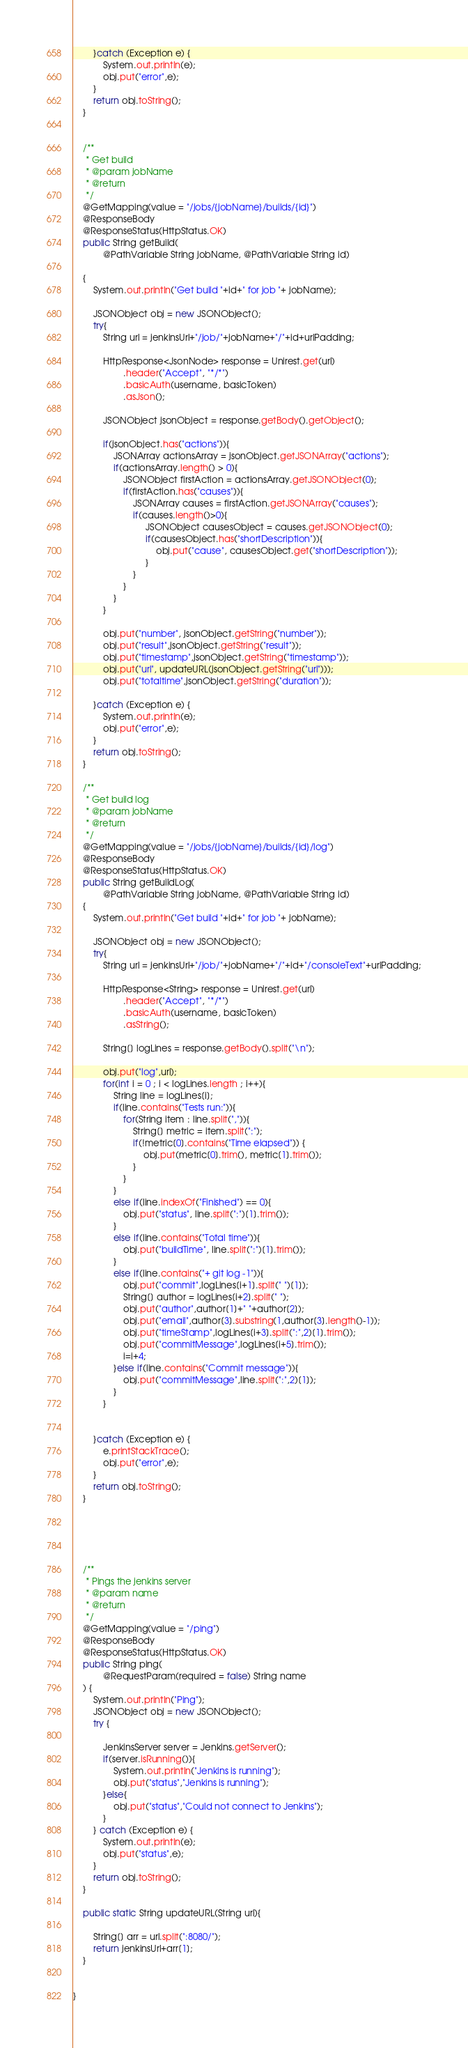Convert code to text. <code><loc_0><loc_0><loc_500><loc_500><_Java_>        }catch (Exception e) {
            System.out.println(e);
            obj.put("error",e);
        }
        return obj.toString();
    }


    /**
     * Get build
     * @param jobName
     * @return
     */
    @GetMapping(value = "/jobs/{jobName}/builds/{id}")
    @ResponseBody
    @ResponseStatus(HttpStatus.OK)
    public String getBuild(
            @PathVariable String jobName, @PathVariable String id)

    {
        System.out.println("Get build "+id+" for job "+ jobName);

        JSONObject obj = new JSONObject();
        try{
            String url = jenkinsUrl+"/job/"+jobName+"/"+id+urlPadding;

            HttpResponse<JsonNode> response = Unirest.get(url)
                    .header("Accept", "*/*")
                    .basicAuth(username, basicToken)
                    .asJson();

            JSONObject jsonObject = response.getBody().getObject();

            if(jsonObject.has("actions")){
                JSONArray actionsArray = jsonObject.getJSONArray("actions");
                if(actionsArray.length() > 0){
                    JSONObject firstAction = actionsArray.getJSONObject(0);
                    if(firstAction.has("causes")){
                        JSONArray causes = firstAction.getJSONArray("causes");
                        if(causes.length()>0){
                             JSONObject causesObject = causes.getJSONObject(0);
                             if(causesObject.has("shortDescription")){
                                 obj.put("cause", causesObject.get("shortDescription"));
                             }
                        }
                    }
                }
            }

            obj.put("number", jsonObject.getString("number"));
            obj.put("result",jsonObject.getString("result"));
            obj.put("timestamp",jsonObject.getString("timestamp"));
            obj.put("url", updateURL(jsonObject.getString("url")));
            obj.put("totaltime",jsonObject.getString("duration"));

        }catch (Exception e) {
            System.out.println(e);
            obj.put("error",e);
        }
        return obj.toString();
    }

    /**
     * Get build log
     * @param jobName
     * @return
     */
    @GetMapping(value = "/jobs/{jobName}/builds/{id}/log")
    @ResponseBody
    @ResponseStatus(HttpStatus.OK)
    public String getBuildLog(
            @PathVariable String jobName, @PathVariable String id)
    {
        System.out.println("Get build "+id+" for job "+ jobName);

        JSONObject obj = new JSONObject();
        try{
            String url = jenkinsUrl+"/job/"+jobName+"/"+id+"/consoleText"+urlPadding;

            HttpResponse<String> response = Unirest.get(url)
                    .header("Accept", "*/*")
                    .basicAuth(username, basicToken)
                    .asString();

            String[] logLines = response.getBody().split("\n");

            obj.put("log",url);
            for(int i = 0 ; i < logLines.length ; i++){
                String line = logLines[i];
                if(line.contains("Tests run:")){
                    for(String item : line.split(",")){
                        String[] metric = item.split(":");
                        if(!metric[0].contains("Time elapsed")) {
                            obj.put(metric[0].trim(), metric[1].trim());
                        }
                    }
                }
                else if(line.indexOf("Finished") == 0){
                    obj.put("status", line.split(":")[1].trim());
                }
                else if(line.contains("Total time")){
                    obj.put("buildTime", line.split(":")[1].trim());
                }
                else if(line.contains("+ git log -1")){
                    obj.put("commit",logLines[i+1].split(" ")[1]);
                    String[] author = logLines[i+2].split(" ");
                    obj.put("author",author[1]+" "+author[2]);
                    obj.put("email",author[3].substring(1,author[3].length()-1));
                    obj.put("timeStamp",logLines[i+3].split(":",2)[1].trim());
                    obj.put("commitMessage",logLines[i+5].trim());
                    i=i+4;
                }else if(line.contains("Commit message")){
                    obj.put("commitMessage",line.split(":",2)[1]);
                }
            }


        }catch (Exception e) {
            e.printStackTrace();
            obj.put("error",e);
        }
        return obj.toString();
    }





    /**
     * Pings the jenkins server
     * @param name
     * @return
     */
    @GetMapping(value = "/ping")
    @ResponseBody
    @ResponseStatus(HttpStatus.OK)
    public String ping(
            @RequestParam(required = false) String name
    ) {
        System.out.println("Ping");
        JSONObject obj = new JSONObject();
        try {

            JenkinsServer server = Jenkins.getServer();
            if(server.isRunning()){
                System.out.println("Jenkins is running");
                obj.put("status","Jenkins is running");
            }else{
                obj.put("status","Could not connect to Jenkins");
            }
        } catch (Exception e) {
            System.out.println(e);
            obj.put("status",e);
        }
        return obj.toString();
    }

    public static String updateURL(String url){

        String[] arr = url.split(":8080/");
        return jenkinsUrl+arr[1];
    }


}
</code> 